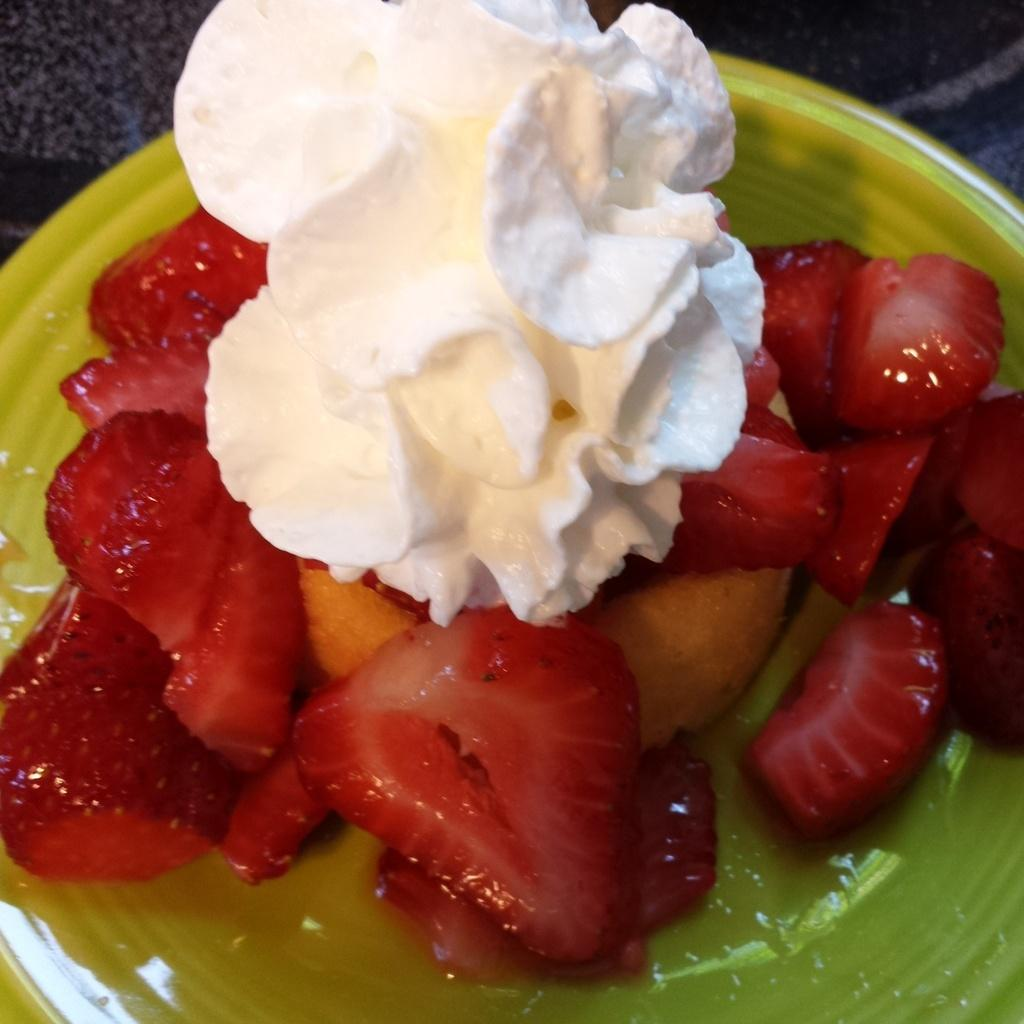What is on the plate that is visible in the image? There are strawberries on the plate. What else is on the plate besides the strawberries? There is cream on the plate. Can you describe the surface that the plate might be resting on? The top of the image might depict a floor. How many beginner skirts can be seen in the image? There are no skirts, let alone beginner skirts, present in the image. 